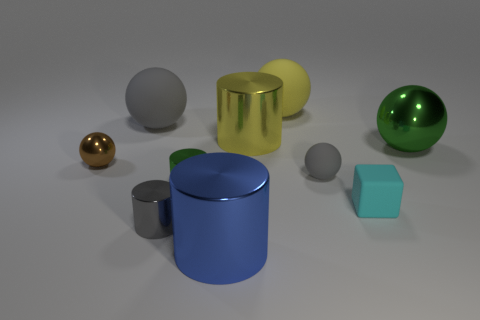Subtract all small gray cylinders. How many cylinders are left? 3 Subtract all yellow spheres. How many spheres are left? 4 Subtract all blue blocks. How many green balls are left? 1 Subtract 1 brown balls. How many objects are left? 9 Subtract all blocks. How many objects are left? 9 Subtract 3 cylinders. How many cylinders are left? 1 Subtract all brown spheres. Subtract all blue cylinders. How many spheres are left? 4 Subtract all yellow blocks. Subtract all blue objects. How many objects are left? 9 Add 8 tiny cyan rubber things. How many tiny cyan rubber things are left? 9 Add 2 small yellow shiny balls. How many small yellow shiny balls exist? 2 